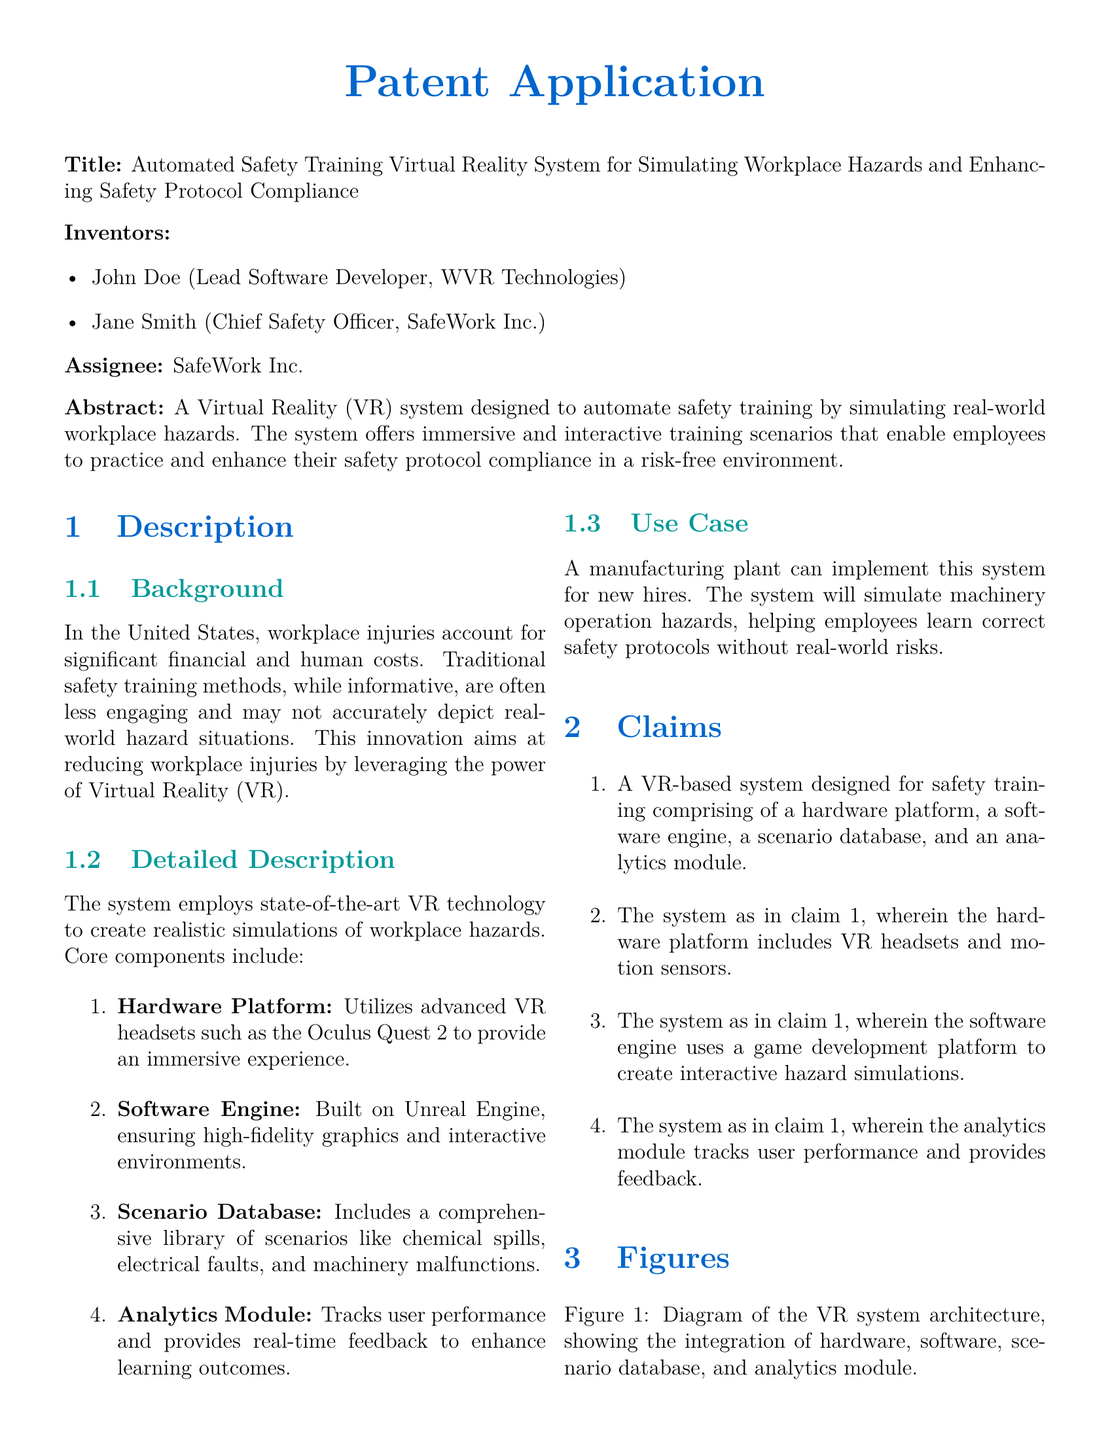What is the title of the patent application? The title is the main descriptor of the document, which identifies its purpose.
Answer: Automated Safety Training Virtual Reality System for Simulating Workplace Hazards and Enhancing Safety Protocol Compliance Who are the inventors of the system? The inventors are the individuals credited with the creation of the technology described in the document.
Answer: John Doe and Jane Smith What technology does the system use to create interactive scenarios? This refers to the software component that enables the VR simulations.
Answer: Unreal Engine What is one of the potential advantages of the system? This highlights a key benefit that the system aims to provide to its users.
Answer: Enhanced Engagement Which VR headset is mentioned as part of the hardware platform? This points to the specific device used to deliver the VR experience in the system.
Answer: Oculus Quest 2 How many components are listed in the system's detailed description? This refers to the total number of distinct parts identified in the specifics of the system.
Answer: Four What is the primary use case mentioned for the system? This reflects the specific context or setting where the system is intended to be implemented.
Answer: Manufacturing plant What does the analytics module do? This asks about the function of a specific component in the system, as described in the document.
Answer: Tracks user performance and provides feedback 